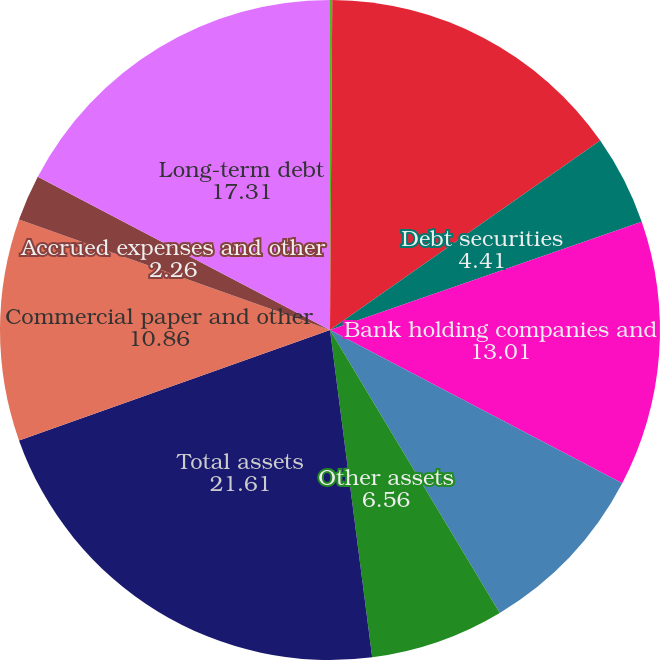Convert chart. <chart><loc_0><loc_0><loc_500><loc_500><pie_chart><fcel>(Dollars in millions)<fcel>Cash held at bank subsidiaries<fcel>Debt securities<fcel>Bank holding companies and<fcel>Nonbank companies and related<fcel>Other assets<fcel>Total assets<fcel>Commercial paper and other<fcel>Accrued expenses and other<fcel>Long-term debt<nl><fcel>0.11%<fcel>15.16%<fcel>4.41%<fcel>13.01%<fcel>8.71%<fcel>6.56%<fcel>21.61%<fcel>10.86%<fcel>2.26%<fcel>17.31%<nl></chart> 